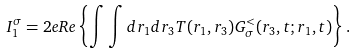<formula> <loc_0><loc_0><loc_500><loc_500>I _ { 1 } ^ { \sigma } = 2 e R e \left \{ \int \int d r _ { 1 } d r _ { 3 } T ( r _ { 1 } , r _ { 3 } ) G _ { \sigma } ^ { < } ( r _ { 3 } , t ; r _ { 1 } , t ) \right \} .</formula> 